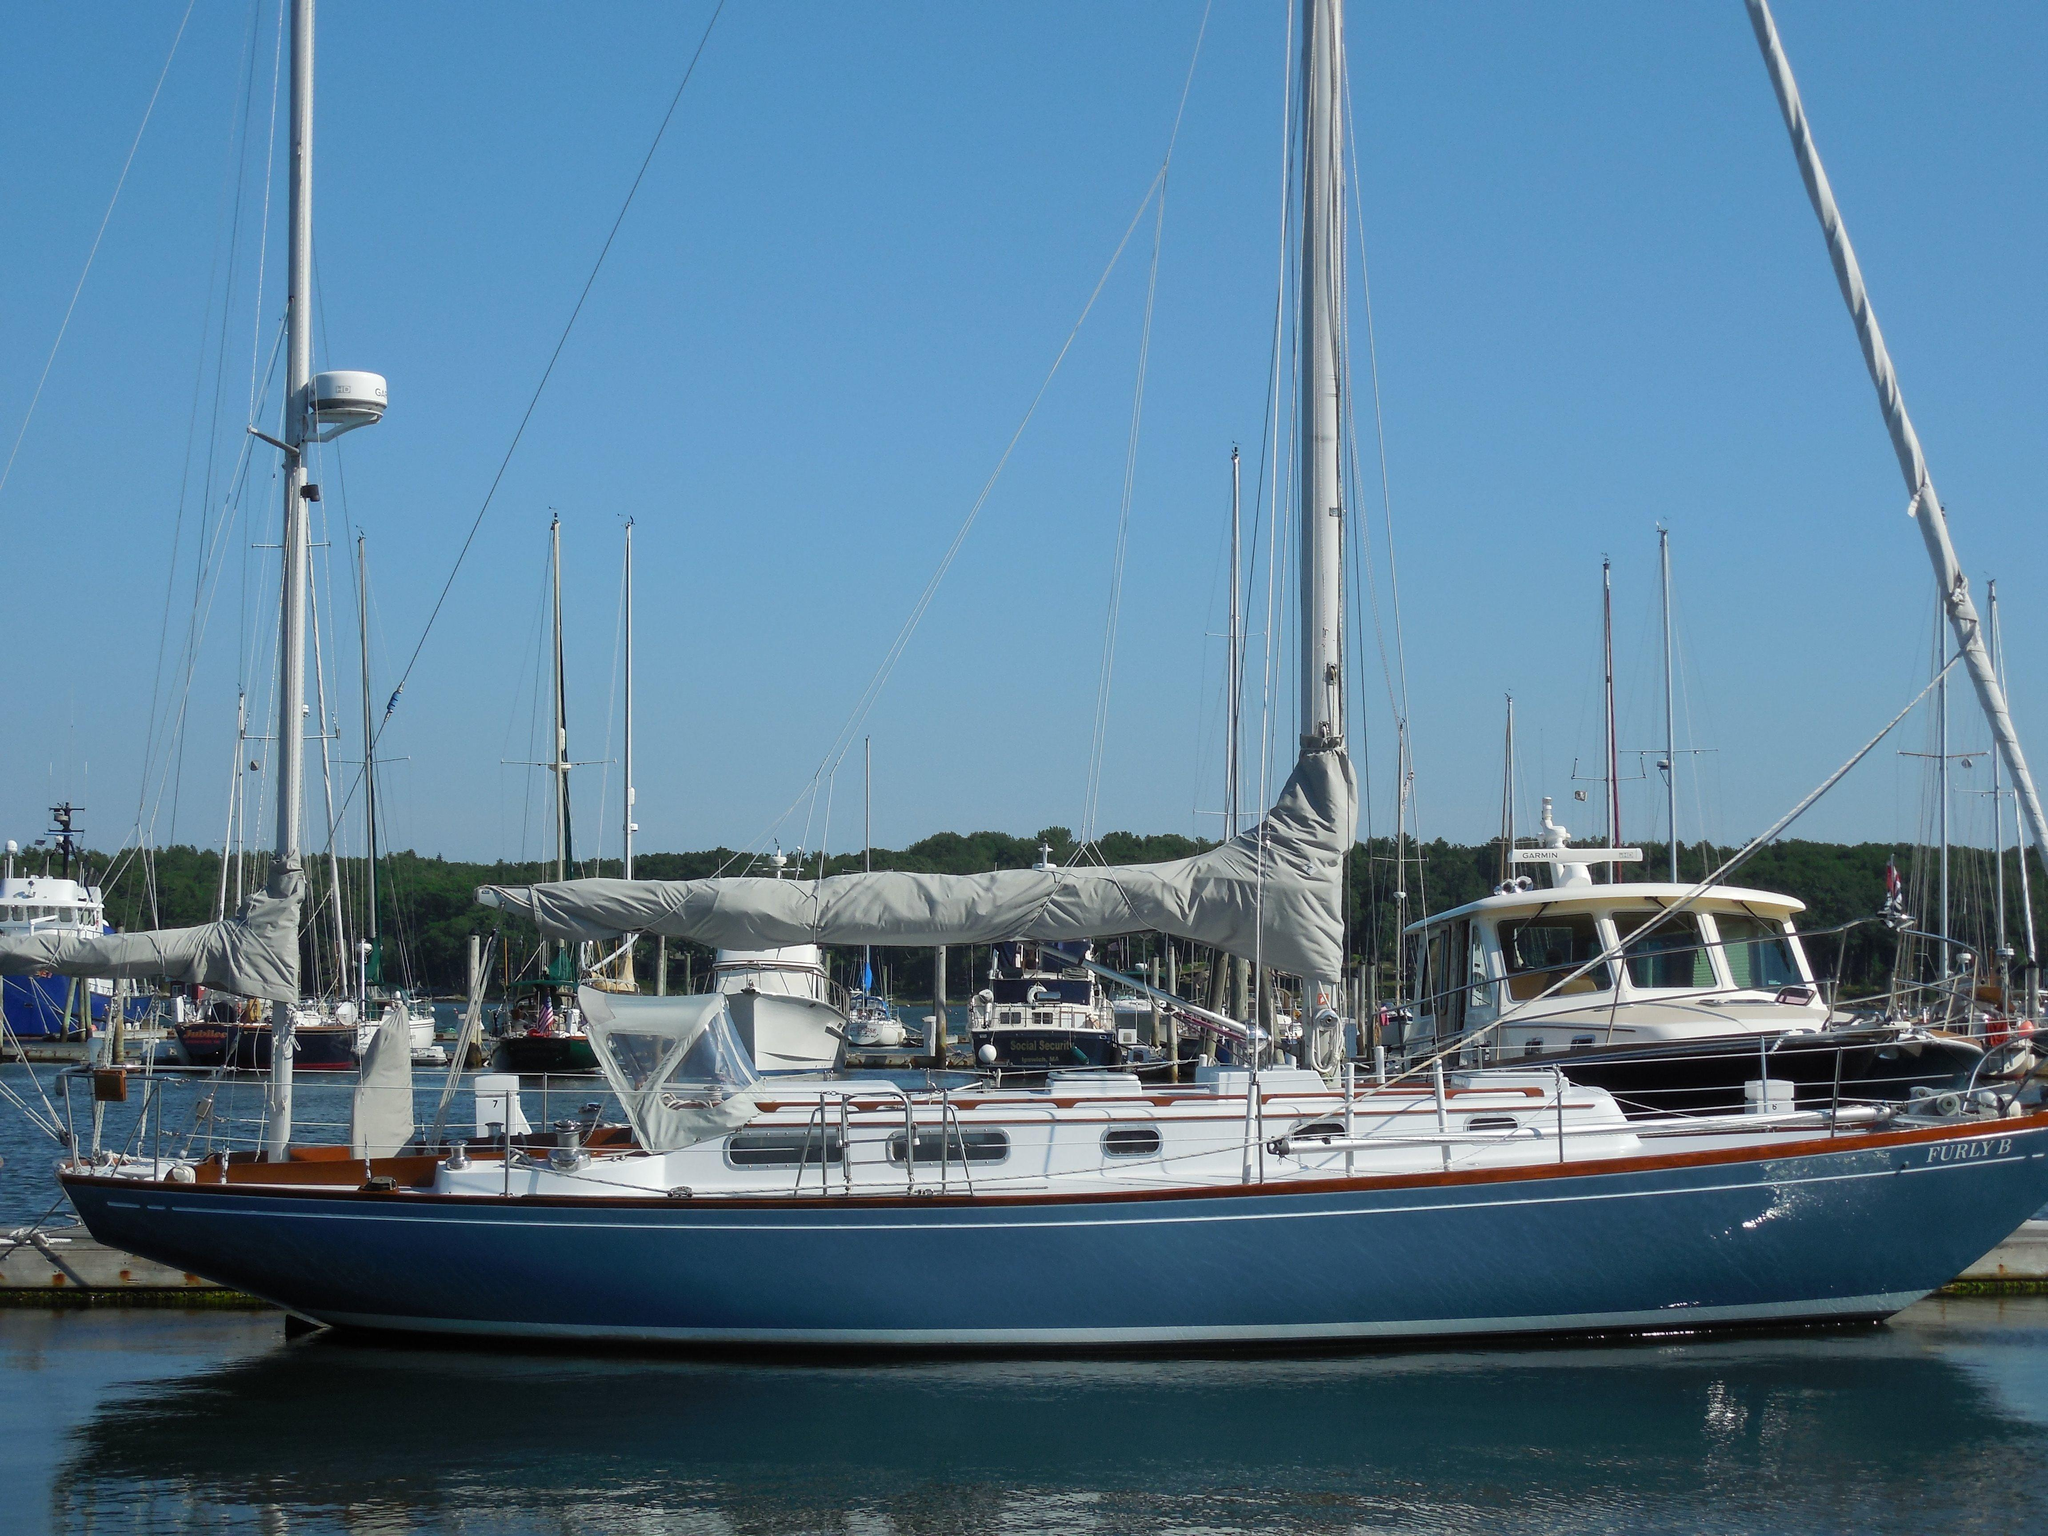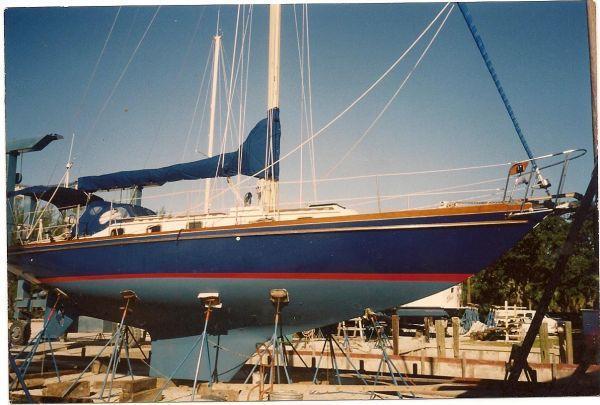The first image is the image on the left, the second image is the image on the right. Analyze the images presented: Is the assertion "At least one boat has three sails up." valid? Answer yes or no. No. The first image is the image on the left, the second image is the image on the right. For the images shown, is this caption "At least one of the images has a sky with nimbus clouds." true? Answer yes or no. No. 